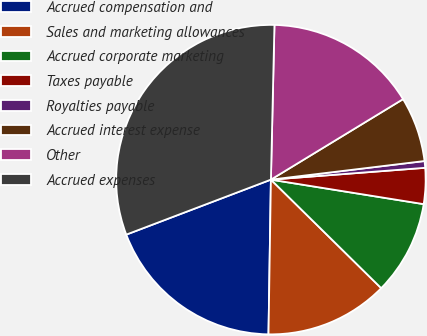Convert chart to OTSL. <chart><loc_0><loc_0><loc_500><loc_500><pie_chart><fcel>Accrued compensation and<fcel>Sales and marketing allowances<fcel>Accrued corporate marketing<fcel>Taxes payable<fcel>Royalties payable<fcel>Accrued interest expense<fcel>Other<fcel>Accrued expenses<nl><fcel>18.97%<fcel>12.88%<fcel>9.84%<fcel>3.75%<fcel>0.7%<fcel>6.79%<fcel>15.93%<fcel>31.15%<nl></chart> 